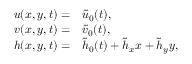Convert formula to latex. <formula><loc_0><loc_0><loc_500><loc_500>\begin{array} { r l } { { u } ( x , y , t ) = } & \tilde { u } _ { 0 } ( t ) , } \\ { { v } ( x , y , t ) = } & \tilde { v } _ { 0 } ( t ) , } \\ { { h } ( x , y , t ) = } & \tilde { h } _ { 0 } ( t ) + \tilde { h } _ { x } x + \tilde { h } _ { y } y , } \end{array}</formula> 